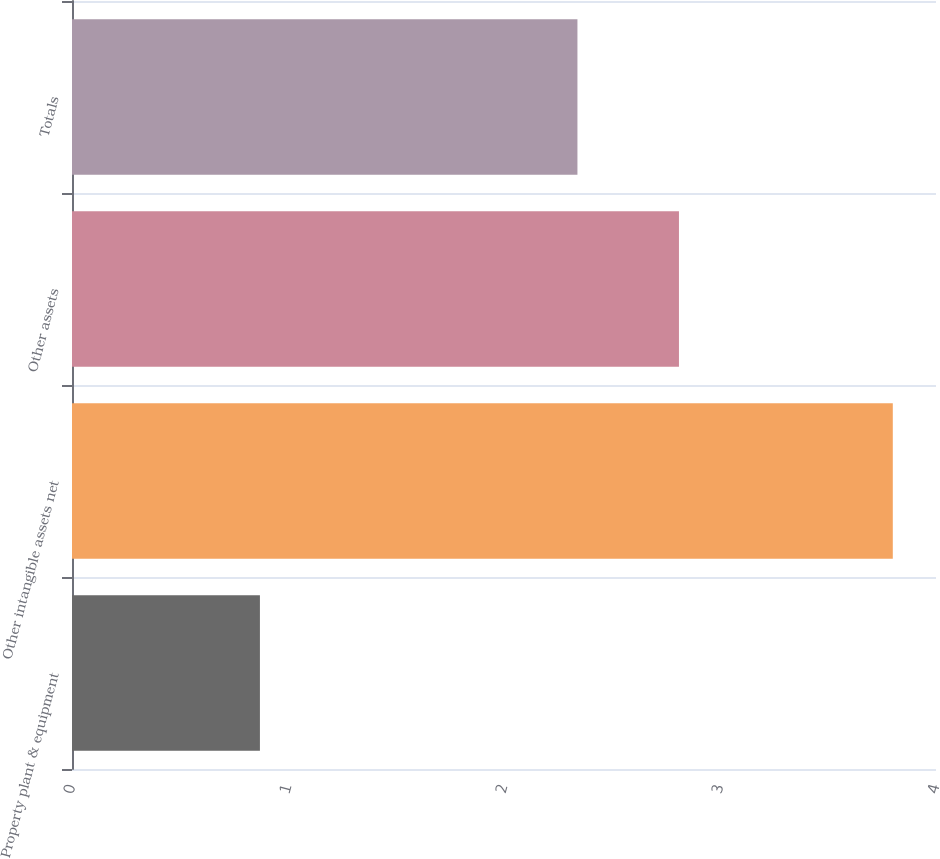Convert chart to OTSL. <chart><loc_0><loc_0><loc_500><loc_500><bar_chart><fcel>Property plant & equipment<fcel>Other intangible assets net<fcel>Other assets<fcel>Totals<nl><fcel>0.87<fcel>3.8<fcel>2.81<fcel>2.34<nl></chart> 